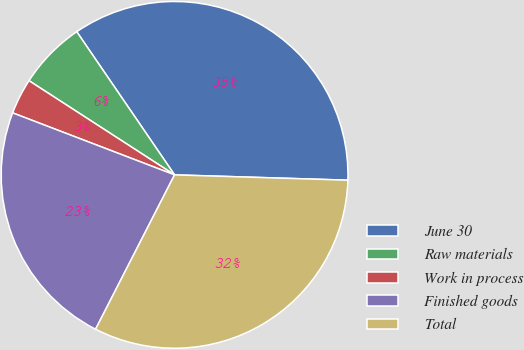Convert chart to OTSL. <chart><loc_0><loc_0><loc_500><loc_500><pie_chart><fcel>June 30<fcel>Raw materials<fcel>Work in process<fcel>Finished goods<fcel>Total<nl><fcel>35.03%<fcel>6.32%<fcel>3.32%<fcel>23.29%<fcel>32.04%<nl></chart> 